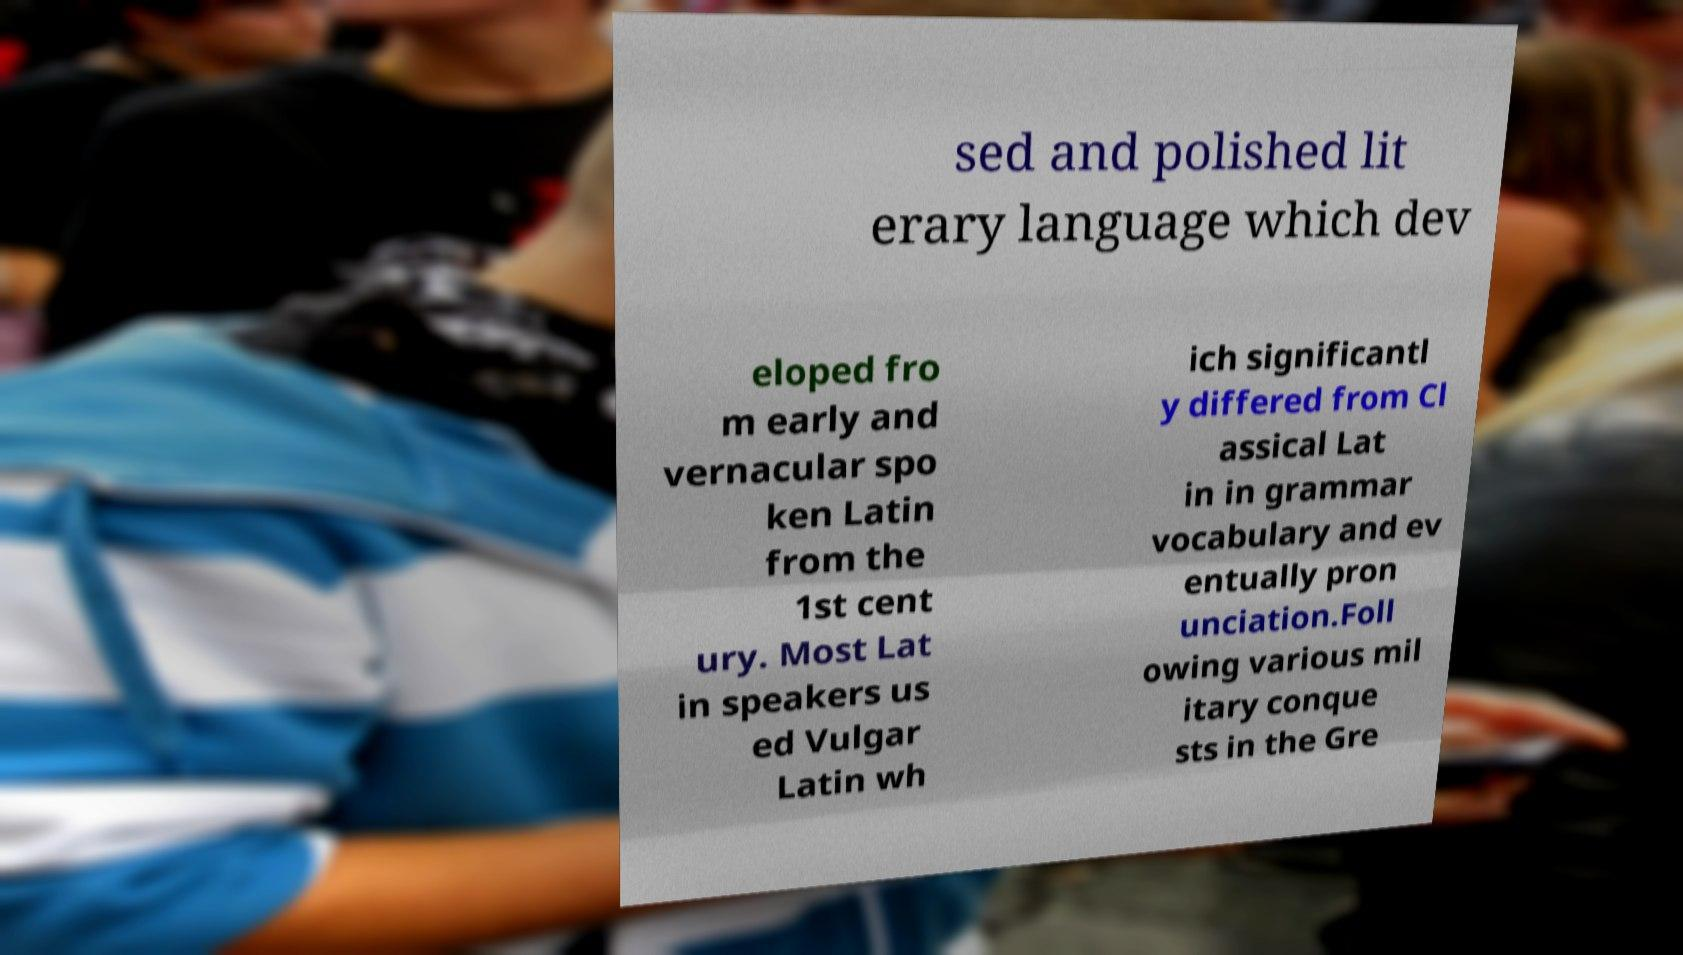Could you extract and type out the text from this image? sed and polished lit erary language which dev eloped fro m early and vernacular spo ken Latin from the 1st cent ury. Most Lat in speakers us ed Vulgar Latin wh ich significantl y differed from Cl assical Lat in in grammar vocabulary and ev entually pron unciation.Foll owing various mil itary conque sts in the Gre 